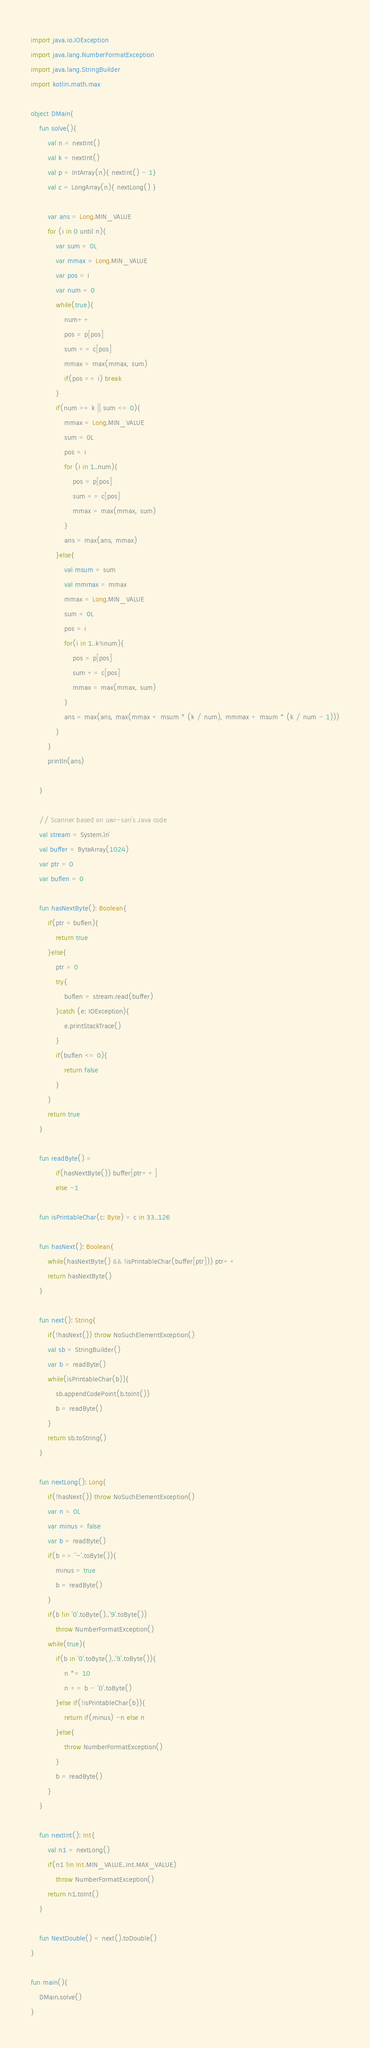<code> <loc_0><loc_0><loc_500><loc_500><_Kotlin_>import java.io.IOException
import java.lang.NumberFormatException
import java.lang.StringBuilder
import kotlin.math.max

object DMain{
    fun solve(){
        val n = nextInt()
        val k = nextInt()
        val p = IntArray(n){ nextInt() - 1}
        val c = LongArray(n){ nextLong() }

        var ans = Long.MIN_VALUE
        for (i in 0 until n){
            var sum = 0L
            var mmax = Long.MIN_VALUE
            var pos = i
            var num = 0
            while(true){
                num++
                pos = p[pos]
                sum += c[pos]
                mmax = max(mmax, sum)
                if(pos == i) break
            }
            if(num >= k || sum <= 0){
                mmax = Long.MIN_VALUE
                sum = 0L
                pos = i
                for (i in 1..num){
                    pos = p[pos]
                    sum += c[pos]
                    mmax = max(mmax, sum)
                }
                ans = max(ans, mmax)
            }else{
                val msum = sum
                val mmmax = mmax
                mmax = Long.MIN_VALUE
                sum = 0L
                pos = i
                for(i in 1..k%num){
                    pos = p[pos]
                    sum += c[pos]
                    mmax = max(mmax, sum)
                }
                ans = max(ans, max(mmax + msum * (k / num), mmmax + msum * (k / num - 1)))
            }
        }
        println(ans)

    }

    // Scanner based on uwi-san's Java code
    val stream = System.`in`
    val buffer = ByteArray(1024)
    var ptr = 0
    var buflen = 0

    fun hasNextByte(): Boolean{
        if(ptr < buflen){
            return true
        }else{
            ptr = 0
            try{
                buflen = stream.read(buffer)
            }catch (e: IOException){
                e.printStackTrace()
            }
            if(buflen <= 0){
                return false
            }
        }
        return true
    }

    fun readByte() =
            if(hasNextByte()) buffer[ptr++]
            else -1

    fun isPrintableChar(c: Byte) = c in 33..126

    fun hasNext(): Boolean{
        while(hasNextByte() && !isPrintableChar(buffer[ptr])) ptr++
        return hasNextByte()
    }

    fun next(): String{
        if(!hasNext()) throw NoSuchElementException()
        val sb = StringBuilder()
        var b = readByte()
        while(isPrintableChar(b)){
            sb.appendCodePoint(b.toInt())
            b = readByte()
        }
        return sb.toString()
    }

    fun nextLong(): Long{
        if(!hasNext()) throw NoSuchElementException()
        var n = 0L
        var minus = false
        var b = readByte()
        if(b == '-'.toByte()){
            minus = true
            b = readByte()
        }
        if(b !in '0'.toByte()..'9'.toByte())
            throw NumberFormatException()
        while(true){
            if(b in '0'.toByte()..'9'.toByte()){
                n *= 10
                n += b - '0'.toByte()
            }else if(!isPrintableChar(b)){
                return if(minus) -n else n
            }else{
                throw NumberFormatException()
            }
            b = readByte()
        }
    }

    fun nextInt(): Int{
        val n1 = nextLong()
        if(n1 !in Int.MIN_VALUE..Int.MAX_VALUE)
            throw NumberFormatException()
        return n1.toInt()
    }

    fun NextDouble() = next().toDouble()
}

fun main(){
    DMain.solve()
}
</code> 